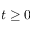Convert formula to latex. <formula><loc_0><loc_0><loc_500><loc_500>t \geq 0</formula> 